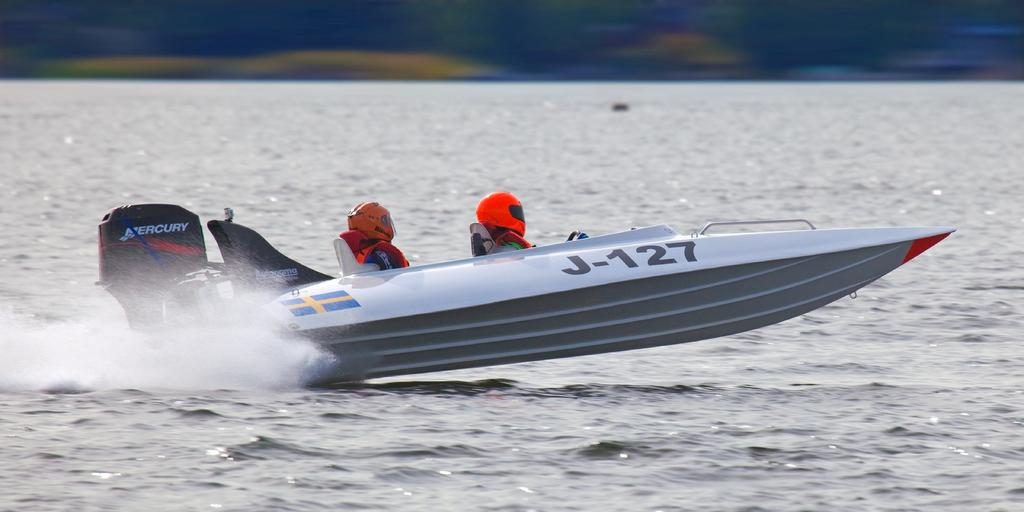Provide a one-sentence caption for the provided image. Two people are wearing helmets while in a speed boat with the ID J-127 painted on the side. 